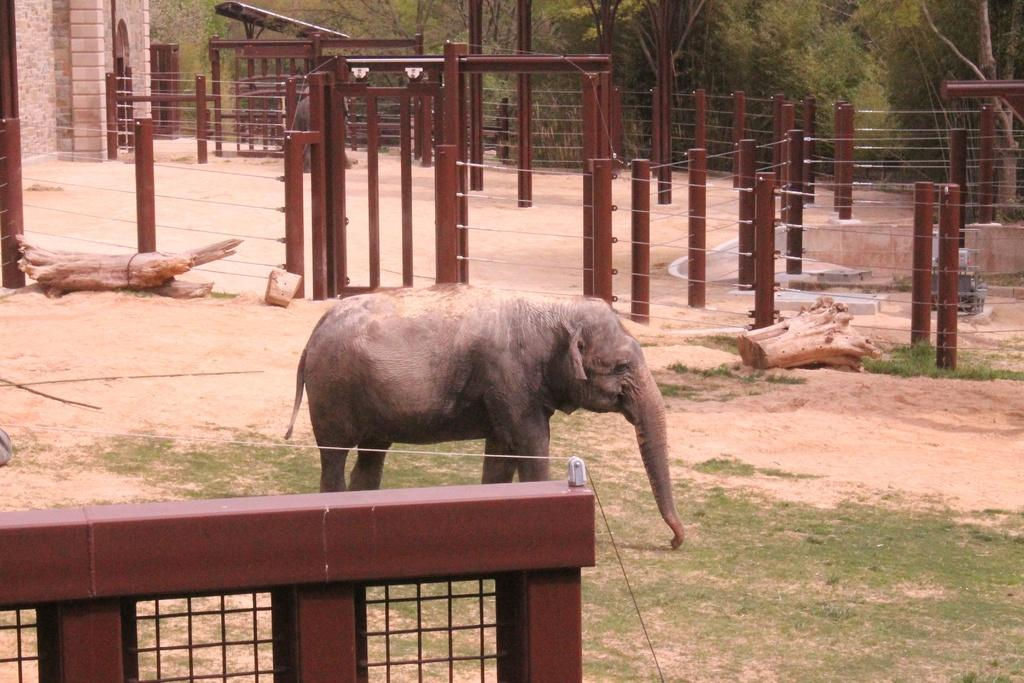What animal is present in the image? There is an elephant in the image. What is the position of the elephant in the image? The elephant is standing. What type of vegetation is visible at the bottom of the image? There is grass at the bottom of the image. What materials can be seen in the middle of the image? There is wood and fencing in the middle of the image. What can be seen in the background of the image? There are trees in the background of the image. Can you see the elephant's toe in the image? The image does not show the elephant's toes, so it is not possible to determine if they are visible. 